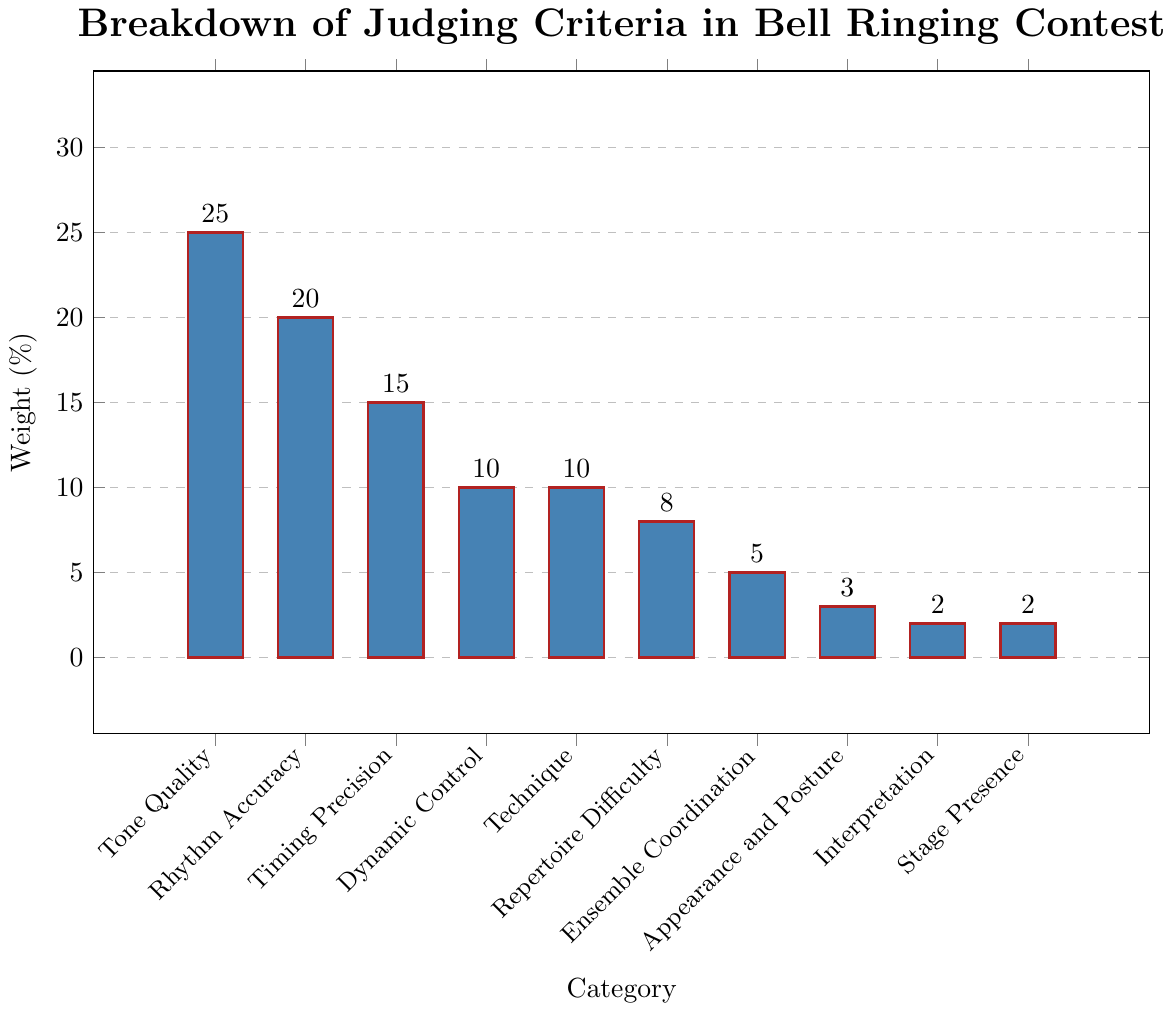What is the highest weight percentage and to which category does it belong? The highest bar in the chart represents the category with the most weight. "Tone Quality" has the highest bar with a weight of 25%.
Answer: 25%, Tone Quality What is the sum of the weights for "Timing Precision" and "Dynamic Control"? Look at the weights for "Timing Precision" and "Dynamic Control": Timing Precision is 15% and Dynamic Control is 10%. Adding these together gives 15% + 10% = 25%.
Answer: 25% Which category has the lowest weight, and what is that weight? Find the smallest bar in the chart which represents the category with the least weight. The "Interpretation" and "Stage Presence" categories both have the lowest weight of 2%.
Answer: Interpretation and Stage Presence, 2% How much more weight does "Rhythm Accuracy" have compared to "Technique"? Identify the weights of "Rhythm Accuracy" and "Technique": Rhythm Accuracy is 20%, and Technique is 10%. The difference is 20% - 10% = 10%.
Answer: 10% What is the average weight of the categories "Appearance and Posture", "Interpretation", and "Stage Presence"? Find the weights for "Appearance and Posture" (3%), "Interpretation" (2%), and "Stage Presence" (2%). The sum is 3% + 2% + 2% = 7%, and the average is 7% / 3 ≈ 2.33%.
Answer: 2.33% How does the weight of "Tone Quality" compare to the combined weight of "Repertoire Difficulty" and "Ensemble Coordination"? The weight of "Tone Quality" is 25%. The combined weight of "Repertoire Difficulty" and "Ensemble Coordination" is 8% + 5% = 13%. "Tone Quality" has 25% - 13% = 12% more weight.
Answer: 12% more Which categories have weights greater than "Technique"? The weight of "Technique" is 10%. The categories with weights greater than 10% are "Tone Quality" (25%), "Rhythm Accuracy" (20%), and "Timing Precision" (15%).
Answer: Tone Quality, Rhythm Accuracy, Timing Precision What fraction of the total weight does the "Ensemble Coordination" category represent? The total weight is 100%. "Ensemble Coordination" has a weight of 5%. The fraction is 5% / 100% = 1/20.
Answer: 1/20 What is the total combined weight of all categories having a weight less than 10%? The categories with weights less than 10% are "Repertoire Difficulty" (8%), "Ensemble Coordination" (5%), "Appearance and Posture" (3%), "Interpretation" (2%), and "Stage Presence" (2%). Their combined weight is 8% + 5% + 3% + 2% + 2% = 20%.
Answer: 20% Which two categories have weights such that their sum equals the weight of "Rhythm Accuracy"? The weight of "Rhythm Accuracy" is 20%. The categories "Technique" (10%) and "Dynamic Control" (10%) together sum to 10% + 10% = 20%, equaling the weight of "Rhythm Accuracy".
Answer: Technique and Dynamic Control 